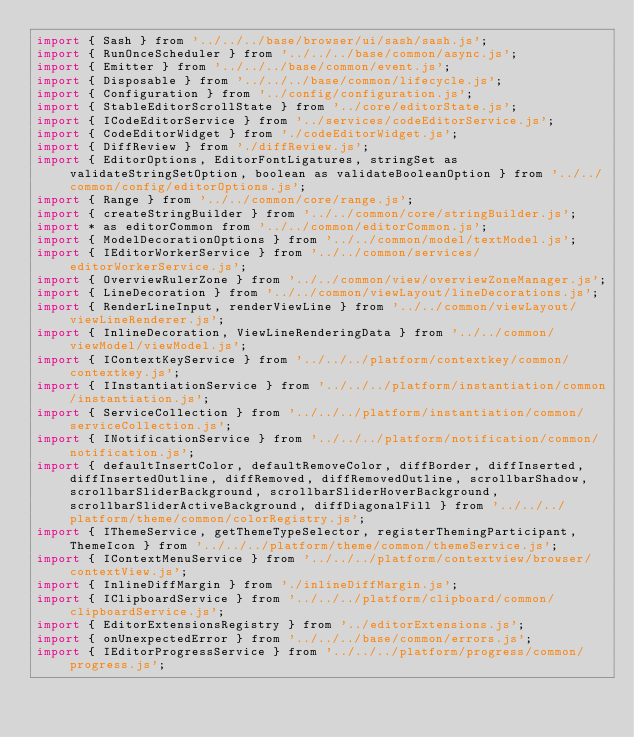Convert code to text. <code><loc_0><loc_0><loc_500><loc_500><_JavaScript_>import { Sash } from '../../../base/browser/ui/sash/sash.js';
import { RunOnceScheduler } from '../../../base/common/async.js';
import { Emitter } from '../../../base/common/event.js';
import { Disposable } from '../../../base/common/lifecycle.js';
import { Configuration } from '../config/configuration.js';
import { StableEditorScrollState } from '../core/editorState.js';
import { ICodeEditorService } from '../services/codeEditorService.js';
import { CodeEditorWidget } from './codeEditorWidget.js';
import { DiffReview } from './diffReview.js';
import { EditorOptions, EditorFontLigatures, stringSet as validateStringSetOption, boolean as validateBooleanOption } from '../../common/config/editorOptions.js';
import { Range } from '../../common/core/range.js';
import { createStringBuilder } from '../../common/core/stringBuilder.js';
import * as editorCommon from '../../common/editorCommon.js';
import { ModelDecorationOptions } from '../../common/model/textModel.js';
import { IEditorWorkerService } from '../../common/services/editorWorkerService.js';
import { OverviewRulerZone } from '../../common/view/overviewZoneManager.js';
import { LineDecoration } from '../../common/viewLayout/lineDecorations.js';
import { RenderLineInput, renderViewLine } from '../../common/viewLayout/viewLineRenderer.js';
import { InlineDecoration, ViewLineRenderingData } from '../../common/viewModel/viewModel.js';
import { IContextKeyService } from '../../../platform/contextkey/common/contextkey.js';
import { IInstantiationService } from '../../../platform/instantiation/common/instantiation.js';
import { ServiceCollection } from '../../../platform/instantiation/common/serviceCollection.js';
import { INotificationService } from '../../../platform/notification/common/notification.js';
import { defaultInsertColor, defaultRemoveColor, diffBorder, diffInserted, diffInsertedOutline, diffRemoved, diffRemovedOutline, scrollbarShadow, scrollbarSliderBackground, scrollbarSliderHoverBackground, scrollbarSliderActiveBackground, diffDiagonalFill } from '../../../platform/theme/common/colorRegistry.js';
import { IThemeService, getThemeTypeSelector, registerThemingParticipant, ThemeIcon } from '../../../platform/theme/common/themeService.js';
import { IContextMenuService } from '../../../platform/contextview/browser/contextView.js';
import { InlineDiffMargin } from './inlineDiffMargin.js';
import { IClipboardService } from '../../../platform/clipboard/common/clipboardService.js';
import { EditorExtensionsRegistry } from '../editorExtensions.js';
import { onUnexpectedError } from '../../../base/common/errors.js';
import { IEditorProgressService } from '../../../platform/progress/common/progress.js';</code> 